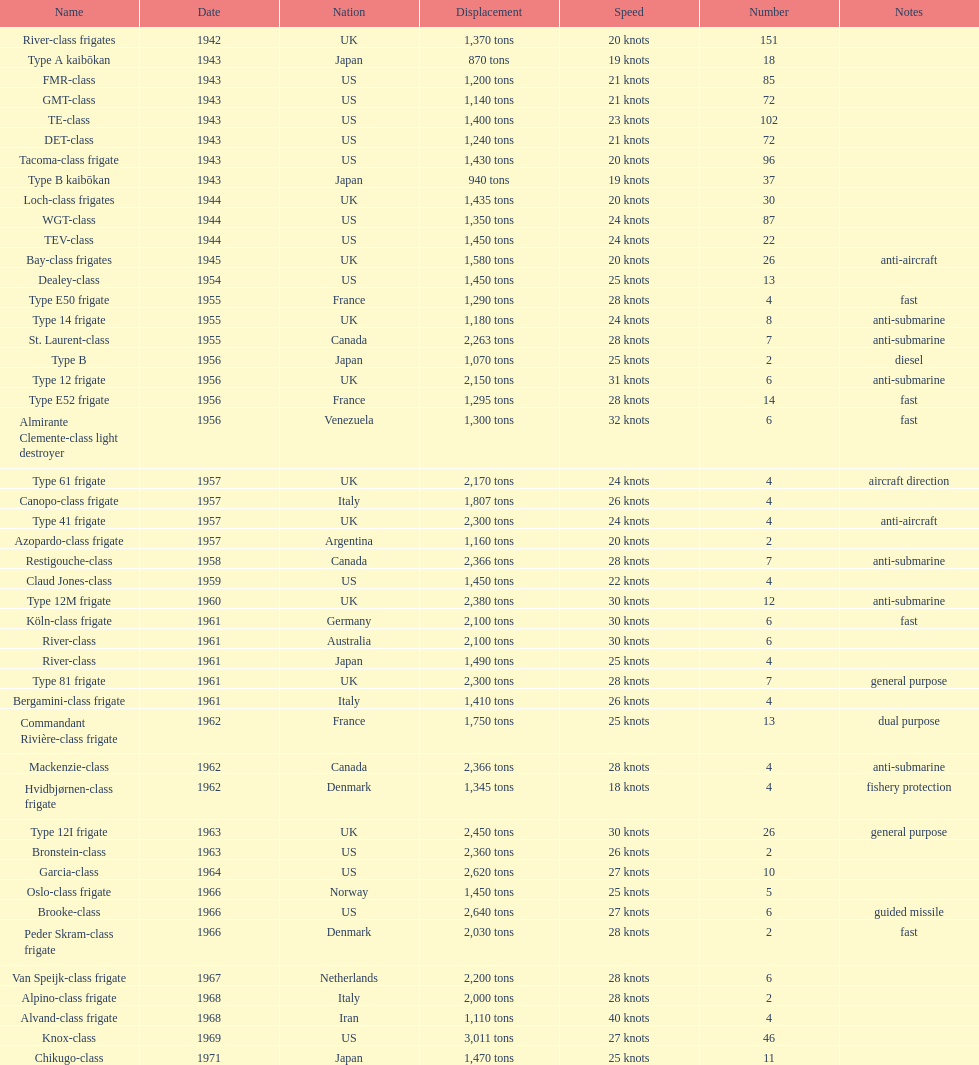What is the displacement in tons for type b? 940 tons. 